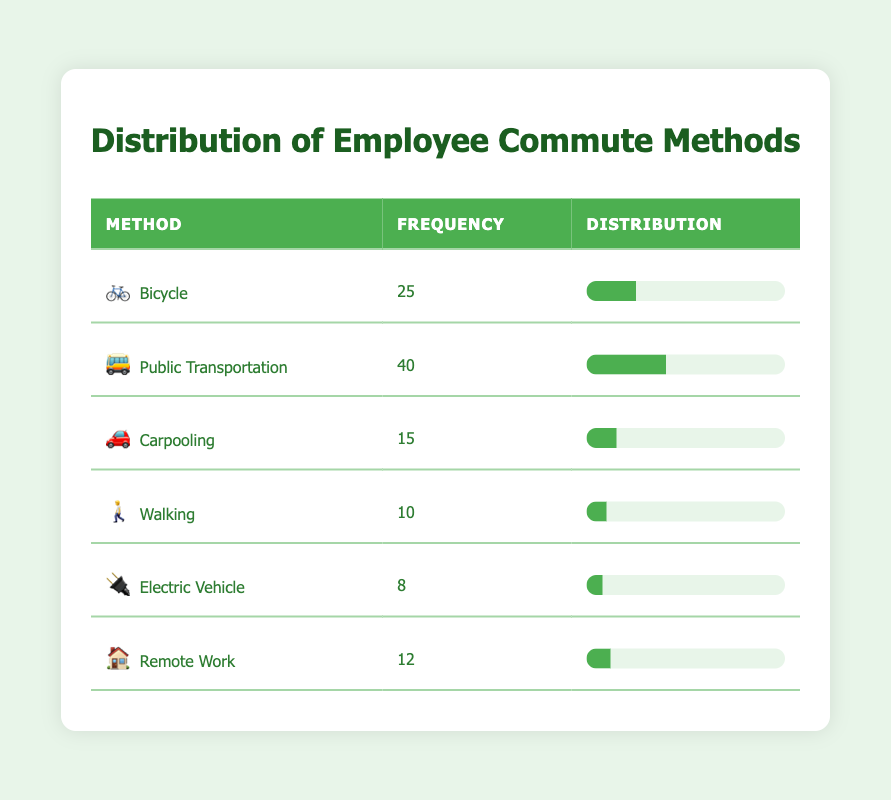What is the most common commute method among employees? The table shows that Public Transportation has the highest frequency with 40, which is greater than the next highest method, Bicycle with 25.
Answer: Public Transportation How many employees commute by Bicycle and Carpooling combined? To find the combined total, we sum the frequencies of Bicycle (25) and Carpooling (15): 25 + 15 = 40.
Answer: 40 Is Electric Vehicle the least used commute method? Electric Vehicle has a frequency of 8, which is lower than all other methods listed in the table (Bicycle: 25, Public Transportation: 40, Carpooling: 15, Walking: 10, Remote Work: 12). Therefore, it is the least used.
Answer: Yes What percentage of employees uses Remote Work compared to those who Bicycle? Remote Work (12) is compared to Bicycle (25). The percentage is calculated as (12 / 25) * 100 = 48%.
Answer: 48% If 100 employees were surveyed, what would be the expected number commuting by Public Transportation? Given the frequency for Public Transportation is 40, we express this as a percentage: (40 / 100) * 100 = 40%. This implies that in a survey of 100 employees, 40 would expect to commute by Public Transportation.
Answer: 40 Which two methods combined are used by more than 60 employees? The frequencies of Public Transportation (40) and Bicycle (25) combined equal 65, which is more than 60 (40 + 25 = 65). No other combination reaches this number.
Answer: Public Transportation and Bicycle What is the total frequency of all employee commute methods listed? The total frequency is computed by summing all frequencies: 25 + 40 + 15 + 10 + 8 + 12 = 110. This represents all employees surveyed.
Answer: 110 How many more employees commute by Bicycle than Walking? Bicycle has a frequency of 25 and Walking has a frequency of 10. The difference is 25 - 10 = 15.
Answer: 15 